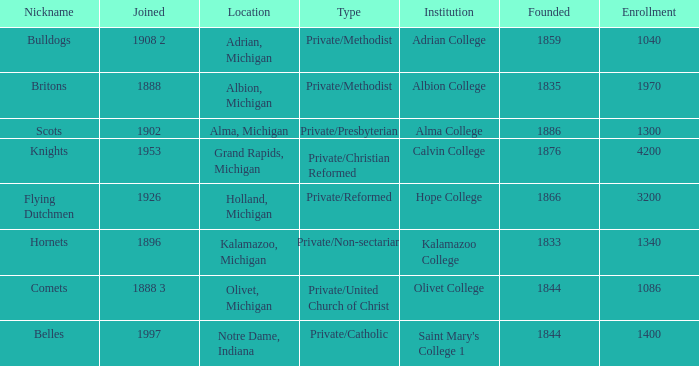Which institutions can be categorized as private/united church of christ? Olivet College. 